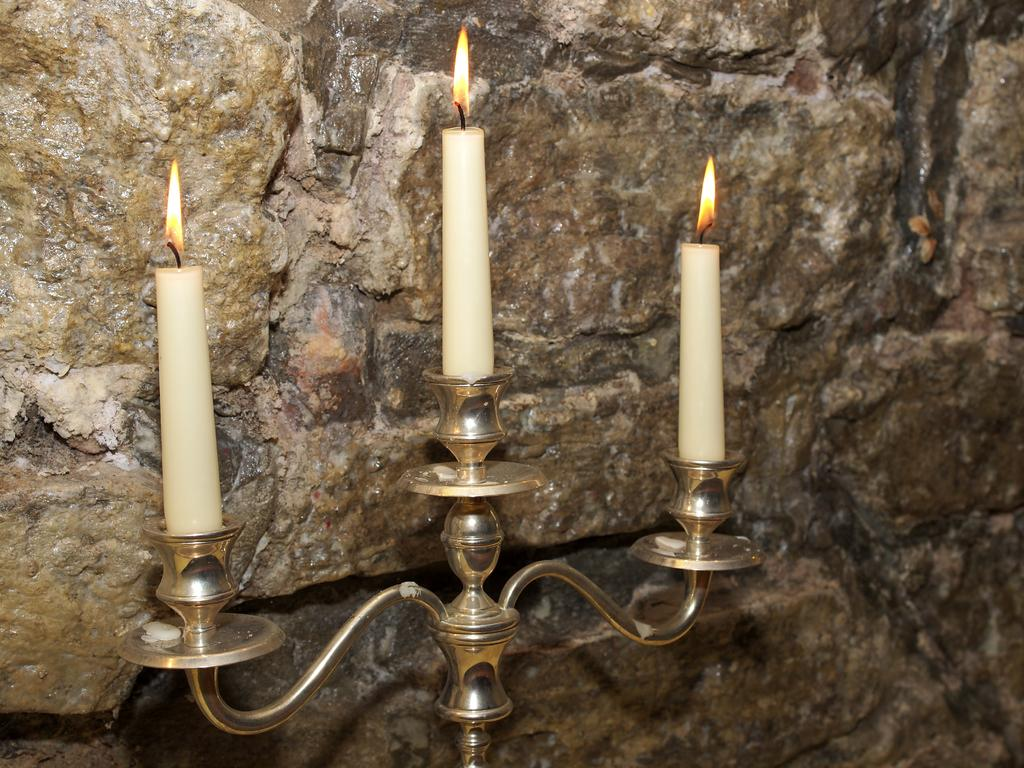What is the main object in the image? There is a candle stand in the image. How many candles are on the candle stand? The candle stand has three candles. What is the state of the candles? The candles have fire. What can be seen behind the candle stand? There is a wall visible in the image. What is unique about the wall? The wall has rocks on it. How does the canvas affect the rainstorm in the image? There is no canvas or rainstorm present in the image. 